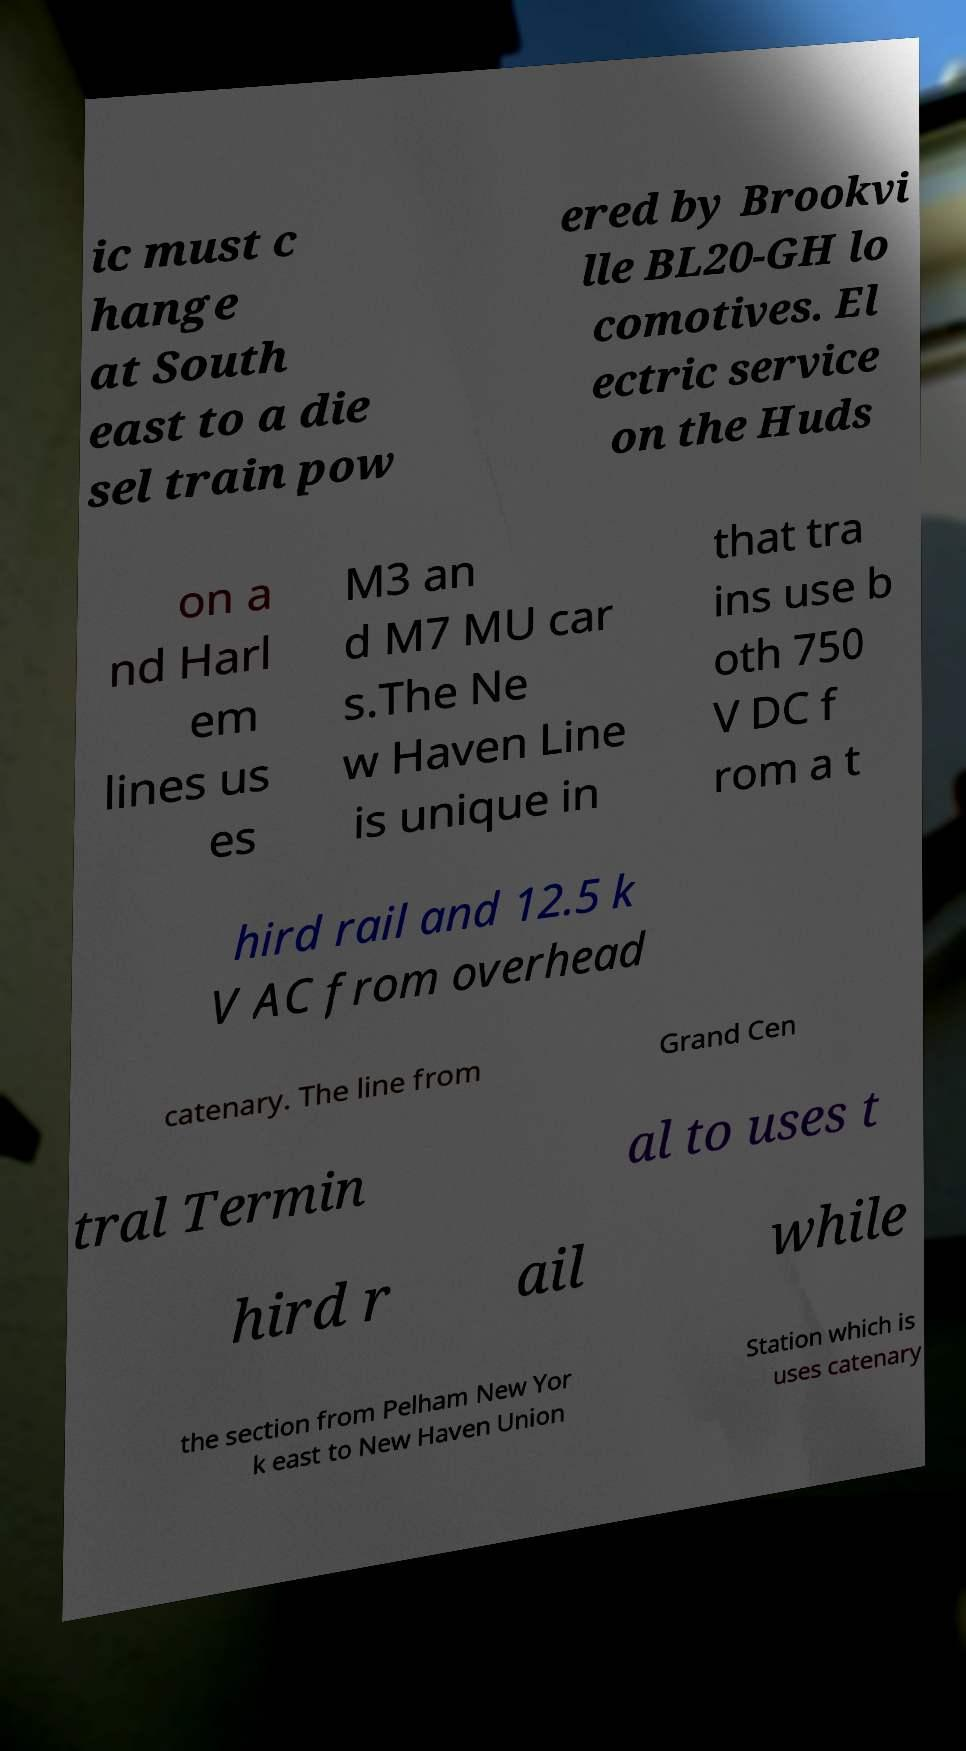Could you assist in decoding the text presented in this image and type it out clearly? ic must c hange at South east to a die sel train pow ered by Brookvi lle BL20-GH lo comotives. El ectric service on the Huds on a nd Harl em lines us es M3 an d M7 MU car s.The Ne w Haven Line is unique in that tra ins use b oth 750 V DC f rom a t hird rail and 12.5 k V AC from overhead catenary. The line from Grand Cen tral Termin al to uses t hird r ail while the section from Pelham New Yor k east to New Haven Union Station which is uses catenary 